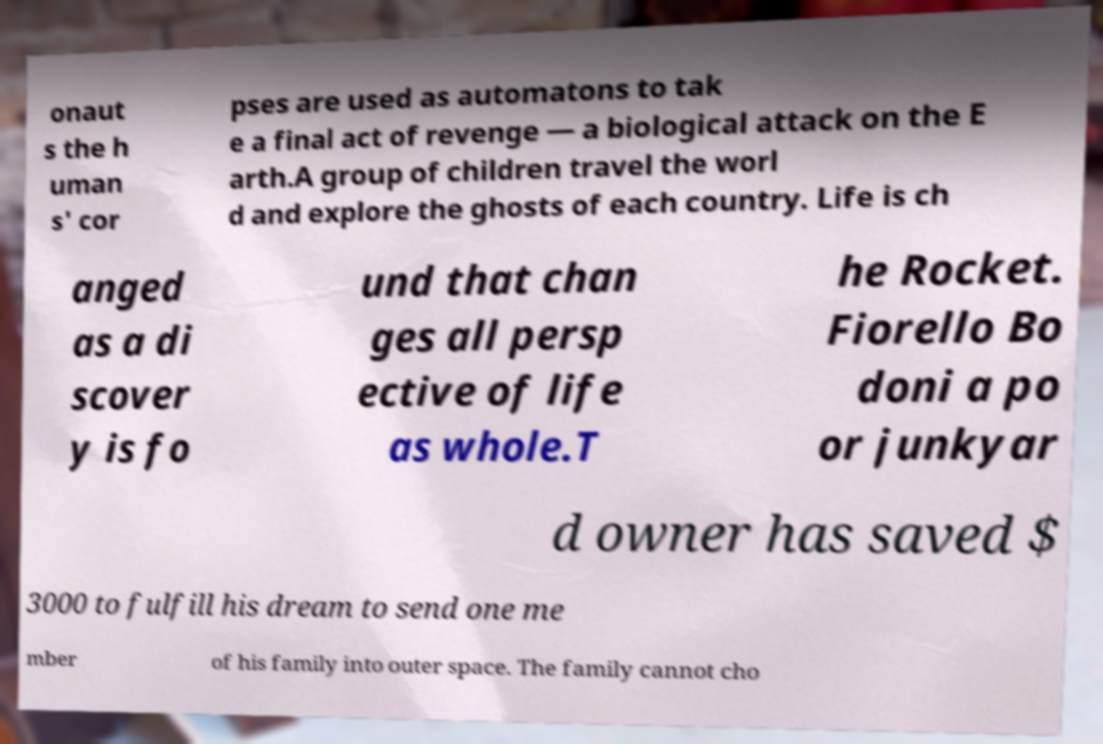There's text embedded in this image that I need extracted. Can you transcribe it verbatim? onaut s the h uman s' cor pses are used as automatons to tak e a final act of revenge — a biological attack on the E arth.A group of children travel the worl d and explore the ghosts of each country. Life is ch anged as a di scover y is fo und that chan ges all persp ective of life as whole.T he Rocket. Fiorello Bo doni a po or junkyar d owner has saved $ 3000 to fulfill his dream to send one me mber of his family into outer space. The family cannot cho 